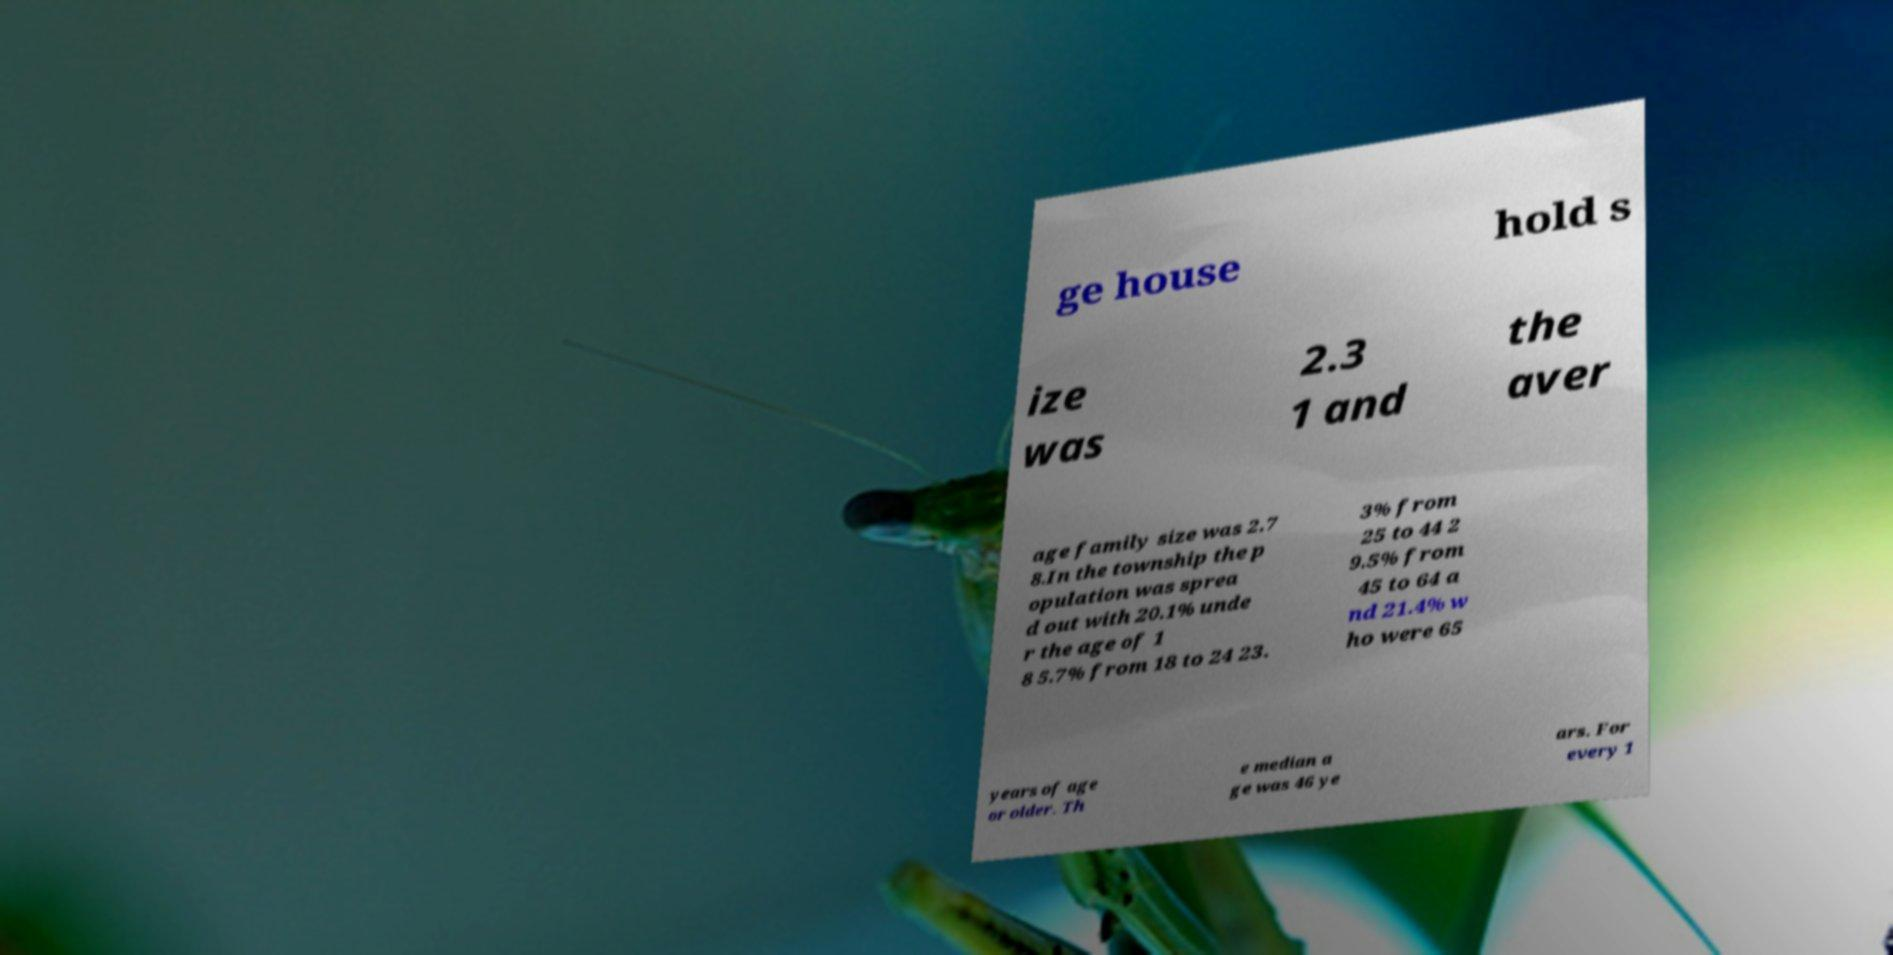I need the written content from this picture converted into text. Can you do that? ge house hold s ize was 2.3 1 and the aver age family size was 2.7 8.In the township the p opulation was sprea d out with 20.1% unde r the age of 1 8 5.7% from 18 to 24 23. 3% from 25 to 44 2 9.5% from 45 to 64 a nd 21.4% w ho were 65 years of age or older. Th e median a ge was 46 ye ars. For every 1 